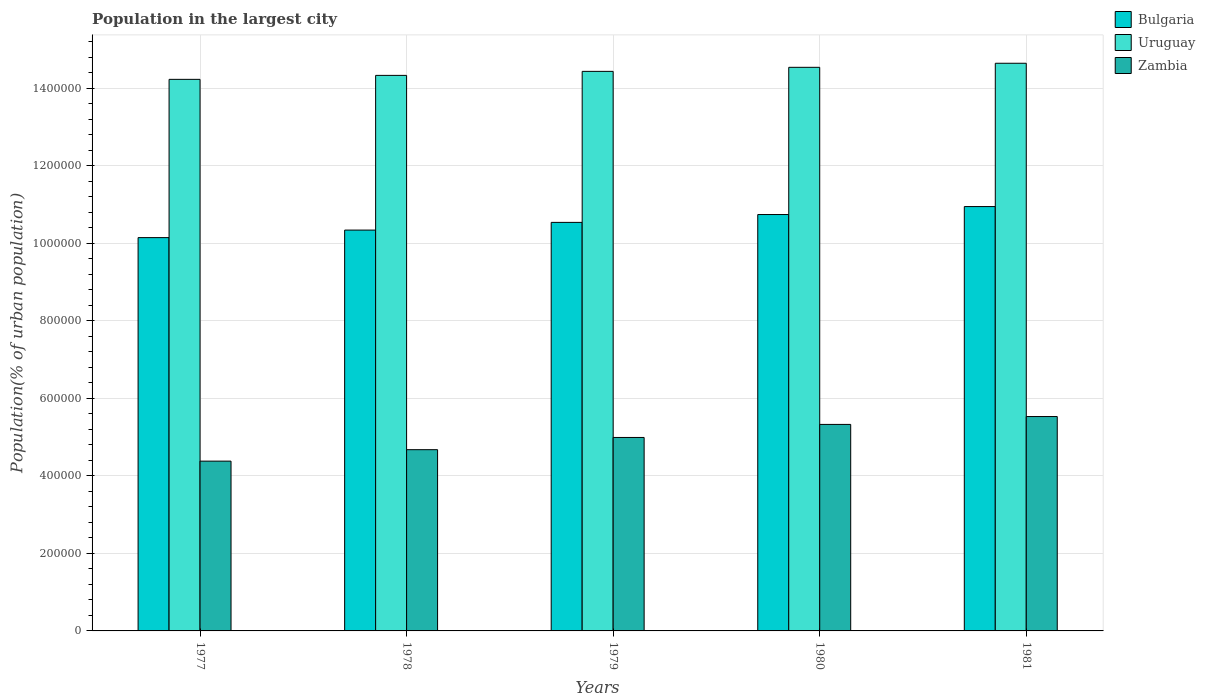How many different coloured bars are there?
Offer a very short reply. 3. How many groups of bars are there?
Provide a short and direct response. 5. Are the number of bars per tick equal to the number of legend labels?
Keep it short and to the point. Yes. Are the number of bars on each tick of the X-axis equal?
Offer a terse response. Yes. In how many cases, is the number of bars for a given year not equal to the number of legend labels?
Offer a very short reply. 0. What is the population in the largest city in Bulgaria in 1981?
Give a very brief answer. 1.09e+06. Across all years, what is the maximum population in the largest city in Zambia?
Give a very brief answer. 5.53e+05. Across all years, what is the minimum population in the largest city in Bulgaria?
Ensure brevity in your answer.  1.01e+06. What is the total population in the largest city in Uruguay in the graph?
Provide a succinct answer. 7.22e+06. What is the difference between the population in the largest city in Uruguay in 1980 and that in 1981?
Your response must be concise. -1.05e+04. What is the difference between the population in the largest city in Zambia in 1981 and the population in the largest city in Uruguay in 1978?
Your answer should be very brief. -8.80e+05. What is the average population in the largest city in Zambia per year?
Provide a succinct answer. 4.98e+05. In the year 1977, what is the difference between the population in the largest city in Uruguay and population in the largest city in Zambia?
Keep it short and to the point. 9.85e+05. In how many years, is the population in the largest city in Bulgaria greater than 720000 %?
Your response must be concise. 5. What is the ratio of the population in the largest city in Zambia in 1977 to that in 1978?
Provide a succinct answer. 0.94. Is the population in the largest city in Zambia in 1978 less than that in 1980?
Ensure brevity in your answer.  Yes. What is the difference between the highest and the second highest population in the largest city in Uruguay?
Provide a succinct answer. 1.05e+04. What is the difference between the highest and the lowest population in the largest city in Bulgaria?
Give a very brief answer. 8.01e+04. Is the sum of the population in the largest city in Uruguay in 1977 and 1978 greater than the maximum population in the largest city in Bulgaria across all years?
Make the answer very short. Yes. What does the 2nd bar from the left in 1981 represents?
Provide a succinct answer. Uruguay. What does the 2nd bar from the right in 1978 represents?
Offer a terse response. Uruguay. How many years are there in the graph?
Your answer should be compact. 5. What is the difference between two consecutive major ticks on the Y-axis?
Make the answer very short. 2.00e+05. Are the values on the major ticks of Y-axis written in scientific E-notation?
Provide a succinct answer. No. Does the graph contain any zero values?
Make the answer very short. No. Does the graph contain grids?
Your answer should be very brief. Yes. Where does the legend appear in the graph?
Ensure brevity in your answer.  Top right. How are the legend labels stacked?
Keep it short and to the point. Vertical. What is the title of the graph?
Your answer should be very brief. Population in the largest city. Does "Angola" appear as one of the legend labels in the graph?
Provide a short and direct response. No. What is the label or title of the Y-axis?
Your response must be concise. Population(% of urban population). What is the Population(% of urban population) of Bulgaria in 1977?
Your answer should be very brief. 1.01e+06. What is the Population(% of urban population) of Uruguay in 1977?
Ensure brevity in your answer.  1.42e+06. What is the Population(% of urban population) of Zambia in 1977?
Offer a very short reply. 4.38e+05. What is the Population(% of urban population) of Bulgaria in 1978?
Offer a terse response. 1.03e+06. What is the Population(% of urban population) in Uruguay in 1978?
Offer a terse response. 1.43e+06. What is the Population(% of urban population) of Zambia in 1978?
Offer a terse response. 4.68e+05. What is the Population(% of urban population) of Bulgaria in 1979?
Offer a terse response. 1.05e+06. What is the Population(% of urban population) in Uruguay in 1979?
Make the answer very short. 1.44e+06. What is the Population(% of urban population) in Zambia in 1979?
Your answer should be very brief. 4.99e+05. What is the Population(% of urban population) in Bulgaria in 1980?
Ensure brevity in your answer.  1.07e+06. What is the Population(% of urban population) in Uruguay in 1980?
Provide a short and direct response. 1.45e+06. What is the Population(% of urban population) of Zambia in 1980?
Your response must be concise. 5.33e+05. What is the Population(% of urban population) of Bulgaria in 1981?
Give a very brief answer. 1.09e+06. What is the Population(% of urban population) of Uruguay in 1981?
Make the answer very short. 1.46e+06. What is the Population(% of urban population) of Zambia in 1981?
Keep it short and to the point. 5.53e+05. Across all years, what is the maximum Population(% of urban population) in Bulgaria?
Offer a terse response. 1.09e+06. Across all years, what is the maximum Population(% of urban population) of Uruguay?
Ensure brevity in your answer.  1.46e+06. Across all years, what is the maximum Population(% of urban population) in Zambia?
Offer a very short reply. 5.53e+05. Across all years, what is the minimum Population(% of urban population) in Bulgaria?
Offer a terse response. 1.01e+06. Across all years, what is the minimum Population(% of urban population) of Uruguay?
Give a very brief answer. 1.42e+06. Across all years, what is the minimum Population(% of urban population) in Zambia?
Make the answer very short. 4.38e+05. What is the total Population(% of urban population) of Bulgaria in the graph?
Provide a succinct answer. 5.27e+06. What is the total Population(% of urban population) in Uruguay in the graph?
Your answer should be very brief. 7.22e+06. What is the total Population(% of urban population) in Zambia in the graph?
Keep it short and to the point. 2.49e+06. What is the difference between the Population(% of urban population) of Bulgaria in 1977 and that in 1978?
Provide a succinct answer. -1.95e+04. What is the difference between the Population(% of urban population) of Uruguay in 1977 and that in 1978?
Provide a short and direct response. -1.03e+04. What is the difference between the Population(% of urban population) in Zambia in 1977 and that in 1978?
Provide a succinct answer. -2.95e+04. What is the difference between the Population(% of urban population) of Bulgaria in 1977 and that in 1979?
Ensure brevity in your answer.  -3.93e+04. What is the difference between the Population(% of urban population) of Uruguay in 1977 and that in 1979?
Ensure brevity in your answer.  -2.06e+04. What is the difference between the Population(% of urban population) in Zambia in 1977 and that in 1979?
Provide a succinct answer. -6.11e+04. What is the difference between the Population(% of urban population) in Bulgaria in 1977 and that in 1980?
Provide a succinct answer. -5.96e+04. What is the difference between the Population(% of urban population) in Uruguay in 1977 and that in 1980?
Ensure brevity in your answer.  -3.11e+04. What is the difference between the Population(% of urban population) in Zambia in 1977 and that in 1980?
Keep it short and to the point. -9.48e+04. What is the difference between the Population(% of urban population) of Bulgaria in 1977 and that in 1981?
Keep it short and to the point. -8.01e+04. What is the difference between the Population(% of urban population) in Uruguay in 1977 and that in 1981?
Provide a short and direct response. -4.15e+04. What is the difference between the Population(% of urban population) in Zambia in 1977 and that in 1981?
Provide a succinct answer. -1.15e+05. What is the difference between the Population(% of urban population) in Bulgaria in 1978 and that in 1979?
Provide a succinct answer. -1.98e+04. What is the difference between the Population(% of urban population) in Uruguay in 1978 and that in 1979?
Provide a short and direct response. -1.03e+04. What is the difference between the Population(% of urban population) in Zambia in 1978 and that in 1979?
Offer a very short reply. -3.15e+04. What is the difference between the Population(% of urban population) in Bulgaria in 1978 and that in 1980?
Keep it short and to the point. -4.01e+04. What is the difference between the Population(% of urban population) in Uruguay in 1978 and that in 1980?
Provide a succinct answer. -2.08e+04. What is the difference between the Population(% of urban population) in Zambia in 1978 and that in 1980?
Give a very brief answer. -6.52e+04. What is the difference between the Population(% of urban population) in Bulgaria in 1978 and that in 1981?
Your response must be concise. -6.07e+04. What is the difference between the Population(% of urban population) of Uruguay in 1978 and that in 1981?
Your answer should be very brief. -3.13e+04. What is the difference between the Population(% of urban population) of Zambia in 1978 and that in 1981?
Your answer should be very brief. -8.55e+04. What is the difference between the Population(% of urban population) in Bulgaria in 1979 and that in 1980?
Provide a succinct answer. -2.03e+04. What is the difference between the Population(% of urban population) in Uruguay in 1979 and that in 1980?
Keep it short and to the point. -1.04e+04. What is the difference between the Population(% of urban population) of Zambia in 1979 and that in 1980?
Ensure brevity in your answer.  -3.37e+04. What is the difference between the Population(% of urban population) in Bulgaria in 1979 and that in 1981?
Provide a short and direct response. -4.08e+04. What is the difference between the Population(% of urban population) of Uruguay in 1979 and that in 1981?
Your answer should be compact. -2.09e+04. What is the difference between the Population(% of urban population) of Zambia in 1979 and that in 1981?
Provide a short and direct response. -5.40e+04. What is the difference between the Population(% of urban population) of Bulgaria in 1980 and that in 1981?
Make the answer very short. -2.06e+04. What is the difference between the Population(% of urban population) in Uruguay in 1980 and that in 1981?
Provide a short and direct response. -1.05e+04. What is the difference between the Population(% of urban population) in Zambia in 1980 and that in 1981?
Keep it short and to the point. -2.03e+04. What is the difference between the Population(% of urban population) in Bulgaria in 1977 and the Population(% of urban population) in Uruguay in 1978?
Your response must be concise. -4.19e+05. What is the difference between the Population(% of urban population) of Bulgaria in 1977 and the Population(% of urban population) of Zambia in 1978?
Give a very brief answer. 5.47e+05. What is the difference between the Population(% of urban population) in Uruguay in 1977 and the Population(% of urban population) in Zambia in 1978?
Offer a terse response. 9.56e+05. What is the difference between the Population(% of urban population) in Bulgaria in 1977 and the Population(% of urban population) in Uruguay in 1979?
Give a very brief answer. -4.29e+05. What is the difference between the Population(% of urban population) of Bulgaria in 1977 and the Population(% of urban population) of Zambia in 1979?
Provide a short and direct response. 5.16e+05. What is the difference between the Population(% of urban population) of Uruguay in 1977 and the Population(% of urban population) of Zambia in 1979?
Provide a short and direct response. 9.24e+05. What is the difference between the Population(% of urban population) in Bulgaria in 1977 and the Population(% of urban population) in Uruguay in 1980?
Offer a very short reply. -4.39e+05. What is the difference between the Population(% of urban population) in Bulgaria in 1977 and the Population(% of urban population) in Zambia in 1980?
Your answer should be compact. 4.82e+05. What is the difference between the Population(% of urban population) of Uruguay in 1977 and the Population(% of urban population) of Zambia in 1980?
Provide a succinct answer. 8.90e+05. What is the difference between the Population(% of urban population) in Bulgaria in 1977 and the Population(% of urban population) in Uruguay in 1981?
Offer a terse response. -4.50e+05. What is the difference between the Population(% of urban population) of Bulgaria in 1977 and the Population(% of urban population) of Zambia in 1981?
Keep it short and to the point. 4.62e+05. What is the difference between the Population(% of urban population) of Uruguay in 1977 and the Population(% of urban population) of Zambia in 1981?
Provide a succinct answer. 8.70e+05. What is the difference between the Population(% of urban population) of Bulgaria in 1978 and the Population(% of urban population) of Uruguay in 1979?
Give a very brief answer. -4.10e+05. What is the difference between the Population(% of urban population) of Bulgaria in 1978 and the Population(% of urban population) of Zambia in 1979?
Your answer should be very brief. 5.35e+05. What is the difference between the Population(% of urban population) in Uruguay in 1978 and the Population(% of urban population) in Zambia in 1979?
Offer a terse response. 9.34e+05. What is the difference between the Population(% of urban population) in Bulgaria in 1978 and the Population(% of urban population) in Uruguay in 1980?
Provide a succinct answer. -4.20e+05. What is the difference between the Population(% of urban population) in Bulgaria in 1978 and the Population(% of urban population) in Zambia in 1980?
Keep it short and to the point. 5.01e+05. What is the difference between the Population(% of urban population) of Uruguay in 1978 and the Population(% of urban population) of Zambia in 1980?
Provide a short and direct response. 9.01e+05. What is the difference between the Population(% of urban population) of Bulgaria in 1978 and the Population(% of urban population) of Uruguay in 1981?
Ensure brevity in your answer.  -4.30e+05. What is the difference between the Population(% of urban population) of Bulgaria in 1978 and the Population(% of urban population) of Zambia in 1981?
Provide a succinct answer. 4.81e+05. What is the difference between the Population(% of urban population) in Uruguay in 1978 and the Population(% of urban population) in Zambia in 1981?
Provide a succinct answer. 8.80e+05. What is the difference between the Population(% of urban population) of Bulgaria in 1979 and the Population(% of urban population) of Uruguay in 1980?
Provide a succinct answer. -4.00e+05. What is the difference between the Population(% of urban population) in Bulgaria in 1979 and the Population(% of urban population) in Zambia in 1980?
Your response must be concise. 5.21e+05. What is the difference between the Population(% of urban population) of Uruguay in 1979 and the Population(% of urban population) of Zambia in 1980?
Provide a succinct answer. 9.11e+05. What is the difference between the Population(% of urban population) in Bulgaria in 1979 and the Population(% of urban population) in Uruguay in 1981?
Provide a short and direct response. -4.11e+05. What is the difference between the Population(% of urban population) of Bulgaria in 1979 and the Population(% of urban population) of Zambia in 1981?
Your answer should be compact. 5.01e+05. What is the difference between the Population(% of urban population) in Uruguay in 1979 and the Population(% of urban population) in Zambia in 1981?
Provide a short and direct response. 8.91e+05. What is the difference between the Population(% of urban population) of Bulgaria in 1980 and the Population(% of urban population) of Uruguay in 1981?
Your answer should be very brief. -3.90e+05. What is the difference between the Population(% of urban population) of Bulgaria in 1980 and the Population(% of urban population) of Zambia in 1981?
Give a very brief answer. 5.21e+05. What is the difference between the Population(% of urban population) in Uruguay in 1980 and the Population(% of urban population) in Zambia in 1981?
Offer a very short reply. 9.01e+05. What is the average Population(% of urban population) of Bulgaria per year?
Make the answer very short. 1.05e+06. What is the average Population(% of urban population) of Uruguay per year?
Offer a terse response. 1.44e+06. What is the average Population(% of urban population) of Zambia per year?
Make the answer very short. 4.98e+05. In the year 1977, what is the difference between the Population(% of urban population) in Bulgaria and Population(% of urban population) in Uruguay?
Provide a succinct answer. -4.08e+05. In the year 1977, what is the difference between the Population(% of urban population) in Bulgaria and Population(% of urban population) in Zambia?
Your response must be concise. 5.77e+05. In the year 1977, what is the difference between the Population(% of urban population) of Uruguay and Population(% of urban population) of Zambia?
Your response must be concise. 9.85e+05. In the year 1978, what is the difference between the Population(% of urban population) of Bulgaria and Population(% of urban population) of Uruguay?
Offer a very short reply. -3.99e+05. In the year 1978, what is the difference between the Population(% of urban population) in Bulgaria and Population(% of urban population) in Zambia?
Offer a very short reply. 5.67e+05. In the year 1978, what is the difference between the Population(% of urban population) of Uruguay and Population(% of urban population) of Zambia?
Your answer should be very brief. 9.66e+05. In the year 1979, what is the difference between the Population(% of urban population) of Bulgaria and Population(% of urban population) of Uruguay?
Ensure brevity in your answer.  -3.90e+05. In the year 1979, what is the difference between the Population(% of urban population) of Bulgaria and Population(% of urban population) of Zambia?
Provide a succinct answer. 5.55e+05. In the year 1979, what is the difference between the Population(% of urban population) of Uruguay and Population(% of urban population) of Zambia?
Your response must be concise. 9.45e+05. In the year 1980, what is the difference between the Population(% of urban population) of Bulgaria and Population(% of urban population) of Uruguay?
Your answer should be compact. -3.80e+05. In the year 1980, what is the difference between the Population(% of urban population) of Bulgaria and Population(% of urban population) of Zambia?
Your response must be concise. 5.42e+05. In the year 1980, what is the difference between the Population(% of urban population) of Uruguay and Population(% of urban population) of Zambia?
Your response must be concise. 9.21e+05. In the year 1981, what is the difference between the Population(% of urban population) of Bulgaria and Population(% of urban population) of Uruguay?
Your response must be concise. -3.70e+05. In the year 1981, what is the difference between the Population(% of urban population) in Bulgaria and Population(% of urban population) in Zambia?
Your response must be concise. 5.42e+05. In the year 1981, what is the difference between the Population(% of urban population) in Uruguay and Population(% of urban population) in Zambia?
Offer a very short reply. 9.12e+05. What is the ratio of the Population(% of urban population) in Bulgaria in 1977 to that in 1978?
Keep it short and to the point. 0.98. What is the ratio of the Population(% of urban population) in Uruguay in 1977 to that in 1978?
Your response must be concise. 0.99. What is the ratio of the Population(% of urban population) in Zambia in 1977 to that in 1978?
Your response must be concise. 0.94. What is the ratio of the Population(% of urban population) in Bulgaria in 1977 to that in 1979?
Provide a short and direct response. 0.96. What is the ratio of the Population(% of urban population) of Uruguay in 1977 to that in 1979?
Keep it short and to the point. 0.99. What is the ratio of the Population(% of urban population) in Zambia in 1977 to that in 1979?
Offer a terse response. 0.88. What is the ratio of the Population(% of urban population) in Bulgaria in 1977 to that in 1980?
Offer a very short reply. 0.94. What is the ratio of the Population(% of urban population) of Uruguay in 1977 to that in 1980?
Your answer should be compact. 0.98. What is the ratio of the Population(% of urban population) in Zambia in 1977 to that in 1980?
Keep it short and to the point. 0.82. What is the ratio of the Population(% of urban population) of Bulgaria in 1977 to that in 1981?
Keep it short and to the point. 0.93. What is the ratio of the Population(% of urban population) of Uruguay in 1977 to that in 1981?
Offer a terse response. 0.97. What is the ratio of the Population(% of urban population) in Zambia in 1977 to that in 1981?
Give a very brief answer. 0.79. What is the ratio of the Population(% of urban population) of Bulgaria in 1978 to that in 1979?
Provide a succinct answer. 0.98. What is the ratio of the Population(% of urban population) in Zambia in 1978 to that in 1979?
Offer a terse response. 0.94. What is the ratio of the Population(% of urban population) in Bulgaria in 1978 to that in 1980?
Your answer should be compact. 0.96. What is the ratio of the Population(% of urban population) in Uruguay in 1978 to that in 1980?
Make the answer very short. 0.99. What is the ratio of the Population(% of urban population) of Zambia in 1978 to that in 1980?
Offer a very short reply. 0.88. What is the ratio of the Population(% of urban population) of Bulgaria in 1978 to that in 1981?
Make the answer very short. 0.94. What is the ratio of the Population(% of urban population) in Uruguay in 1978 to that in 1981?
Ensure brevity in your answer.  0.98. What is the ratio of the Population(% of urban population) of Zambia in 1978 to that in 1981?
Keep it short and to the point. 0.85. What is the ratio of the Population(% of urban population) of Bulgaria in 1979 to that in 1980?
Keep it short and to the point. 0.98. What is the ratio of the Population(% of urban population) in Zambia in 1979 to that in 1980?
Provide a succinct answer. 0.94. What is the ratio of the Population(% of urban population) of Bulgaria in 1979 to that in 1981?
Your answer should be compact. 0.96. What is the ratio of the Population(% of urban population) of Uruguay in 1979 to that in 1981?
Your answer should be very brief. 0.99. What is the ratio of the Population(% of urban population) of Zambia in 1979 to that in 1981?
Give a very brief answer. 0.9. What is the ratio of the Population(% of urban population) of Bulgaria in 1980 to that in 1981?
Offer a very short reply. 0.98. What is the ratio of the Population(% of urban population) of Uruguay in 1980 to that in 1981?
Keep it short and to the point. 0.99. What is the ratio of the Population(% of urban population) in Zambia in 1980 to that in 1981?
Give a very brief answer. 0.96. What is the difference between the highest and the second highest Population(% of urban population) of Bulgaria?
Provide a short and direct response. 2.06e+04. What is the difference between the highest and the second highest Population(% of urban population) of Uruguay?
Offer a very short reply. 1.05e+04. What is the difference between the highest and the second highest Population(% of urban population) of Zambia?
Make the answer very short. 2.03e+04. What is the difference between the highest and the lowest Population(% of urban population) in Bulgaria?
Offer a terse response. 8.01e+04. What is the difference between the highest and the lowest Population(% of urban population) in Uruguay?
Make the answer very short. 4.15e+04. What is the difference between the highest and the lowest Population(% of urban population) of Zambia?
Provide a short and direct response. 1.15e+05. 